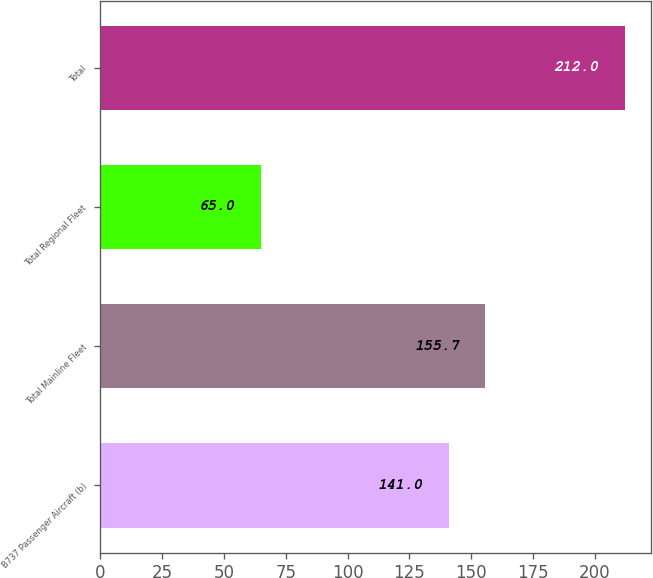<chart> <loc_0><loc_0><loc_500><loc_500><bar_chart><fcel>B737 Passenger Aircraft (b)<fcel>Total Mainline Fleet<fcel>Total Regional Fleet<fcel>Total<nl><fcel>141<fcel>155.7<fcel>65<fcel>212<nl></chart> 